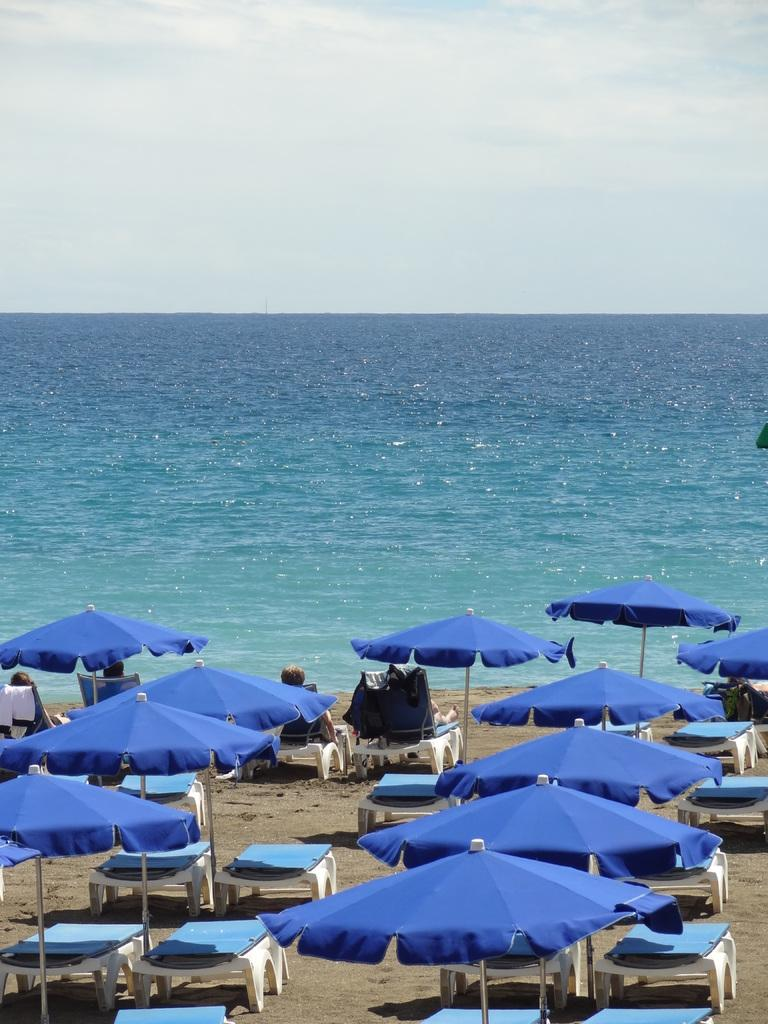What type of furniture is present in the image? There are tables in the image. What is providing shade for the tables? The tables are under an umbrella. What are the people on the tables doing? There are people sitting on the tables. What can be seen in the distance in the image? There is a sea visible in the background of the image. What else is visible in the background of the image? The sky is visible in the background of the image. What type of insect is being served on the tables in the image? There are no insects present in the image; the people are sitting on the tables. 